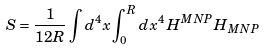Convert formula to latex. <formula><loc_0><loc_0><loc_500><loc_500>S = \frac { 1 } { 1 2 R } \int d ^ { 4 } x \int _ { 0 } ^ { R } d x ^ { 4 } \, H ^ { M N P } H _ { M N P }</formula> 